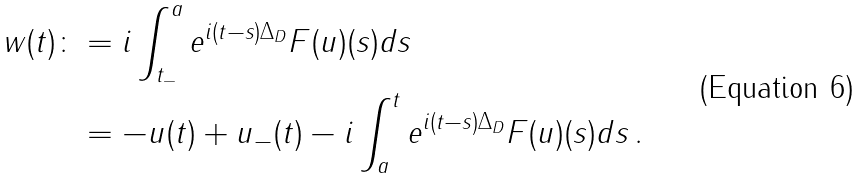Convert formula to latex. <formula><loc_0><loc_0><loc_500><loc_500>w ( t ) \colon & = i \int _ { t _ { - } } ^ { a } e ^ { i ( t - s ) \Delta _ { D } } F ( u ) ( s ) d s \\ & = - u ( t ) + u _ { - } ( t ) - i \int _ { a } ^ { t } e ^ { i ( t - s ) \Delta _ { D } } F ( u ) ( s ) d s \, .</formula> 